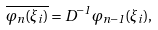Convert formula to latex. <formula><loc_0><loc_0><loc_500><loc_500>\overline { \varphi _ { n } ( \xi _ { i } ) } = D ^ { - 1 } \varphi _ { n - 1 } ( \xi _ { i } ) ,</formula> 